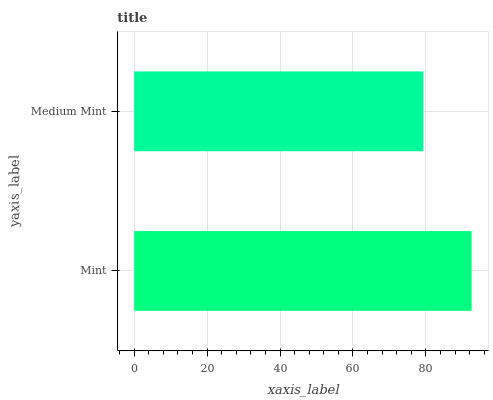Is Medium Mint the minimum?
Answer yes or no. Yes. Is Mint the maximum?
Answer yes or no. Yes. Is Medium Mint the maximum?
Answer yes or no. No. Is Mint greater than Medium Mint?
Answer yes or no. Yes. Is Medium Mint less than Mint?
Answer yes or no. Yes. Is Medium Mint greater than Mint?
Answer yes or no. No. Is Mint less than Medium Mint?
Answer yes or no. No. Is Mint the high median?
Answer yes or no. Yes. Is Medium Mint the low median?
Answer yes or no. Yes. Is Medium Mint the high median?
Answer yes or no. No. Is Mint the low median?
Answer yes or no. No. 